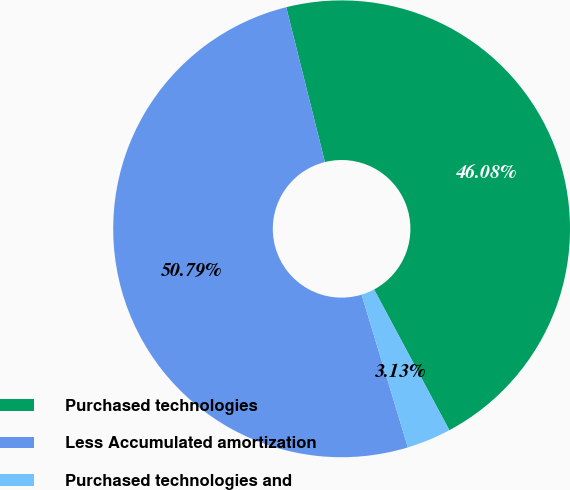Convert chart. <chart><loc_0><loc_0><loc_500><loc_500><pie_chart><fcel>Purchased technologies<fcel>Less Accumulated amortization<fcel>Purchased technologies and<nl><fcel>46.08%<fcel>50.79%<fcel>3.13%<nl></chart> 